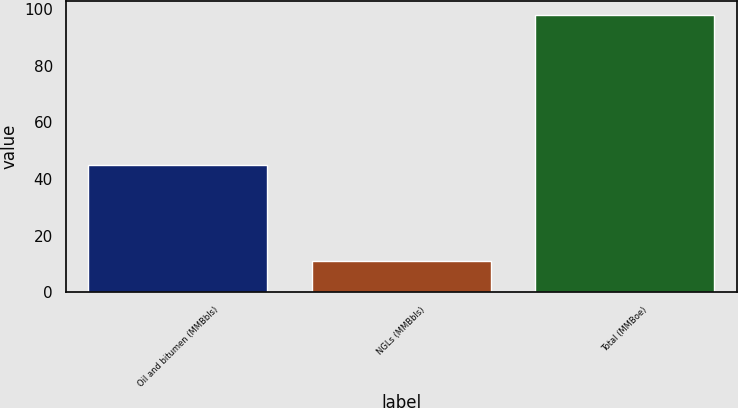Convert chart. <chart><loc_0><loc_0><loc_500><loc_500><bar_chart><fcel>Oil and bitumen (MMBbls)<fcel>NGLs (MMBbls)<fcel>Total (MMBoe)<nl><fcel>45<fcel>11<fcel>98<nl></chart> 